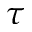<formula> <loc_0><loc_0><loc_500><loc_500>\tau</formula> 